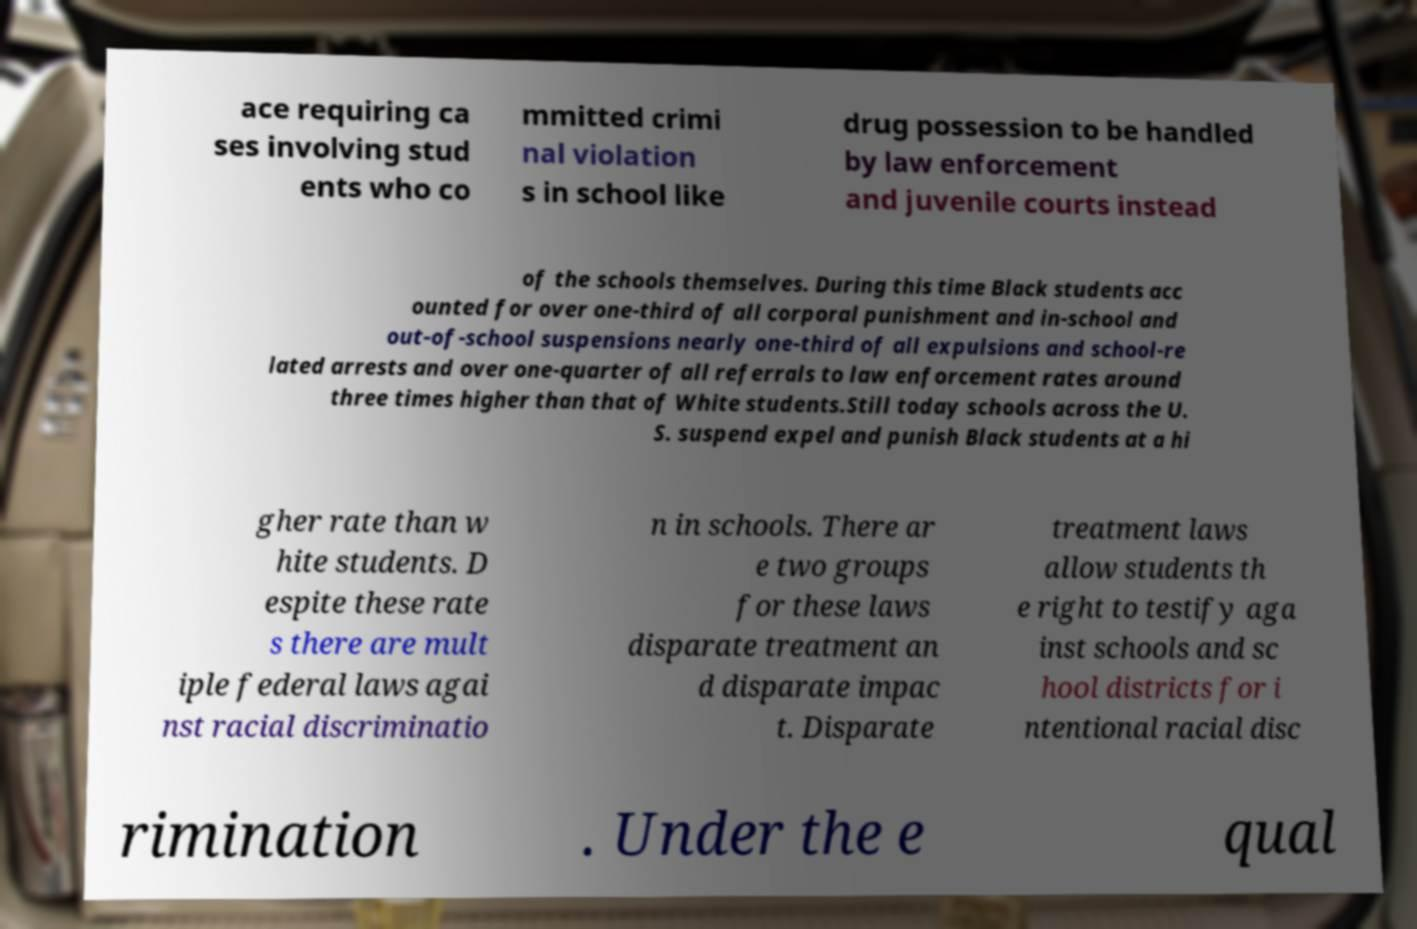There's text embedded in this image that I need extracted. Can you transcribe it verbatim? ace requiring ca ses involving stud ents who co mmitted crimi nal violation s in school like drug possession to be handled by law enforcement and juvenile courts instead of the schools themselves. During this time Black students acc ounted for over one-third of all corporal punishment and in-school and out-of-school suspensions nearly one-third of all expulsions and school-re lated arrests and over one-quarter of all referrals to law enforcement rates around three times higher than that of White students.Still today schools across the U. S. suspend expel and punish Black students at a hi gher rate than w hite students. D espite these rate s there are mult iple federal laws agai nst racial discriminatio n in schools. There ar e two groups for these laws disparate treatment an d disparate impac t. Disparate treatment laws allow students th e right to testify aga inst schools and sc hool districts for i ntentional racial disc rimination . Under the e qual 